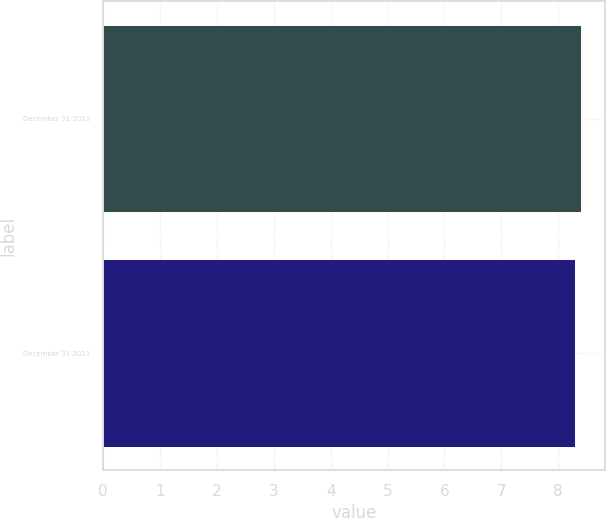Convert chart. <chart><loc_0><loc_0><loc_500><loc_500><bar_chart><fcel>December 31 2012<fcel>December 31 2011<nl><fcel>8.4<fcel>8.3<nl></chart> 